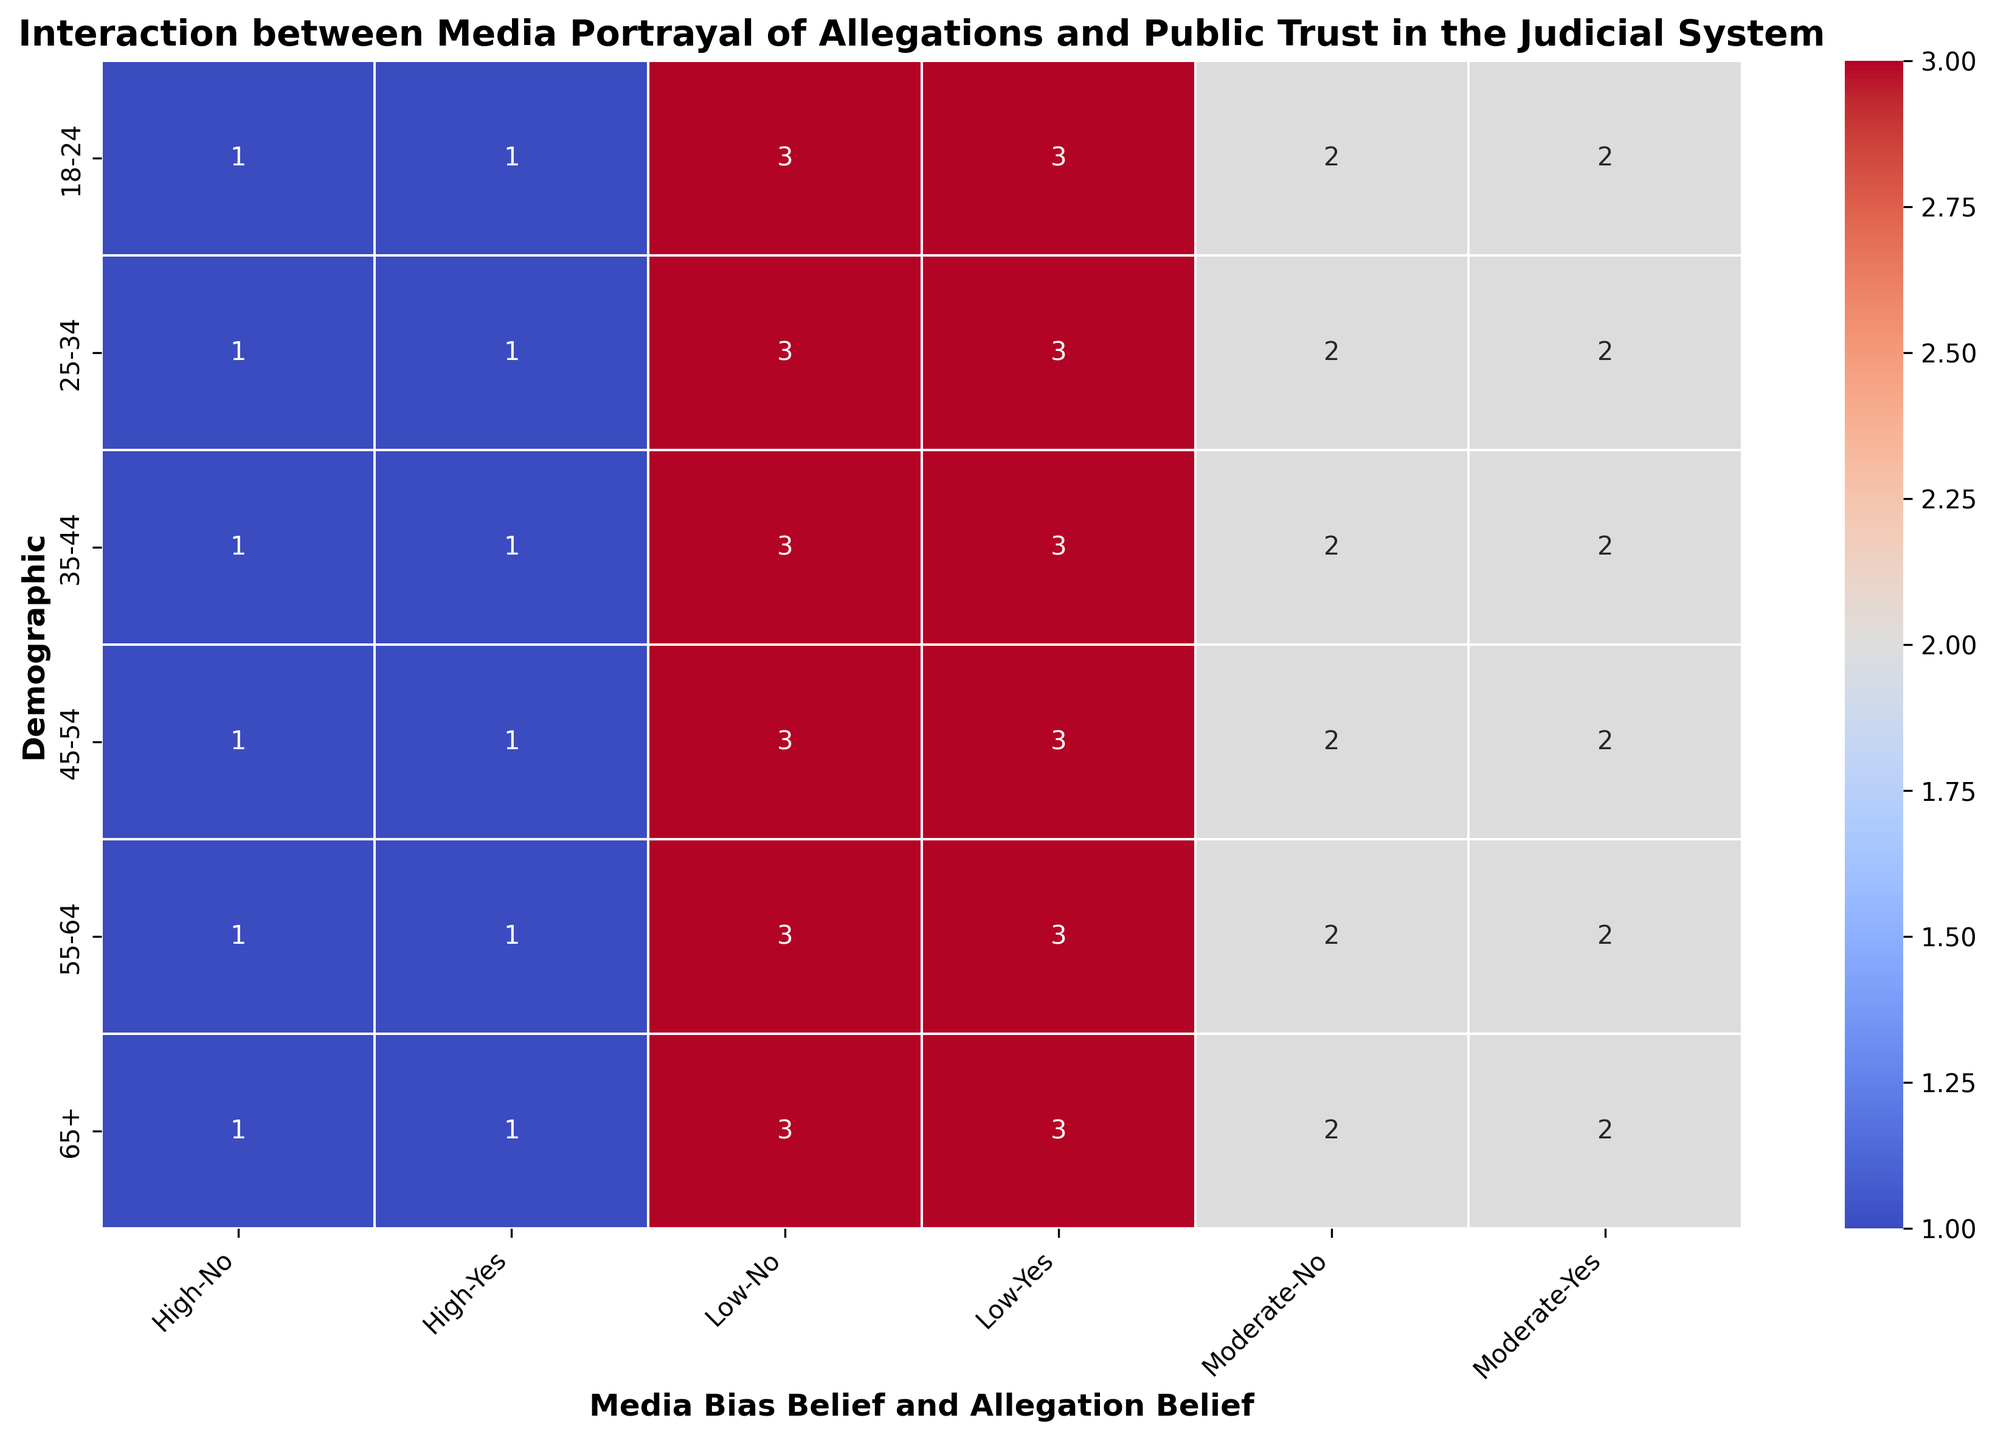What demographic shows the highest trust in the judicial system when they believe there is low media bias and believe allegations to be true? Look at the 'Low' media bias and 'Yes' allegation belief across all demographic groups and identify the one with the highest trust level. All the demographics show 'High' trust in the judicial system in this category.
Answer: All demographics Which demographic shows the lowest trust in the judicial system when they believe there is high media bias and do not believe allegations? Refer to the interaction between 'High' media bias belief and 'No' allegation belief across demographics and determine the trust level. All demographics show 'Low' trust in the judicial system here.
Answer: All demographics Is there any demographic that shows a 'Medium' trust level in the judicial system when they believe there is moderate media bias and believe allegations? Check the 'Moderate' media bias and 'Yes' allegation belief across all demographics. All demographics reflect 'Medium' trust in the judicial system.
Answer: All demographics For the 35-44 demographic, compare the trust levels when they believe media bias is high versus when it is low, irrespective of their belief in allegations. Look at the trust levels for the 35-44 demographic under 'High' and 'Low' media bias belief, ignoring the 'Allegation Belief'. 'High' shows 'Low' trust while 'Low' shows 'High' trust.
Answer: 'High' low, 'Low' high Which trust level is more associated with 'Moderate' media bias belief, 'Medium' or 'High', across all demographics? Check the trust levels under 'Moderate' media bias across all demographics. 'Moderate' media bias consistently shows 'Medium' trust levels across all demographics.
Answer: Medium For belief in allegations ('Yes'), compare trust levels between 'Low' and 'High' media bias beliefs for the 18-24 demographic. Analyze the 18-24 demographic under 'Low' and 'High' media bias beliefs with 'Yes' allegation belief. 'Low' shows 'High' trust, 'High' shows 'Low' trust.
Answer: 'Low' high, 'High' low 